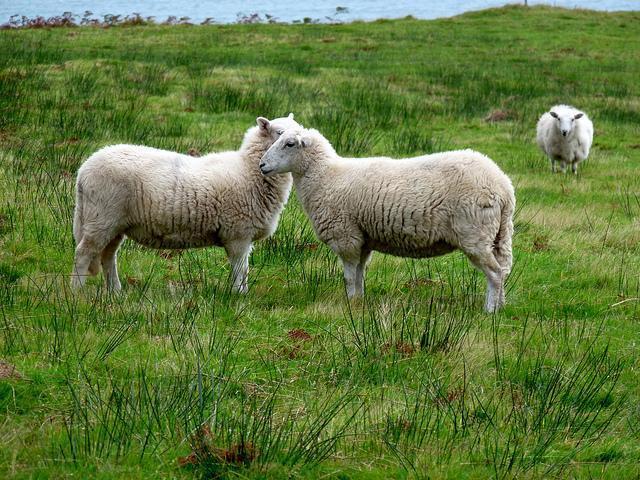How many sheep are in the picture?
Give a very brief answer. 3. How many lambs?
Give a very brief answer. 3. How many sheep are there?
Give a very brief answer. 3. How many sheep can be seen?
Give a very brief answer. 3. How many people are dressed in red?
Give a very brief answer. 0. 